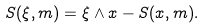Convert formula to latex. <formula><loc_0><loc_0><loc_500><loc_500>S ( \xi , { m } ) = \xi \wedge x - S ( x , { m } ) .</formula> 